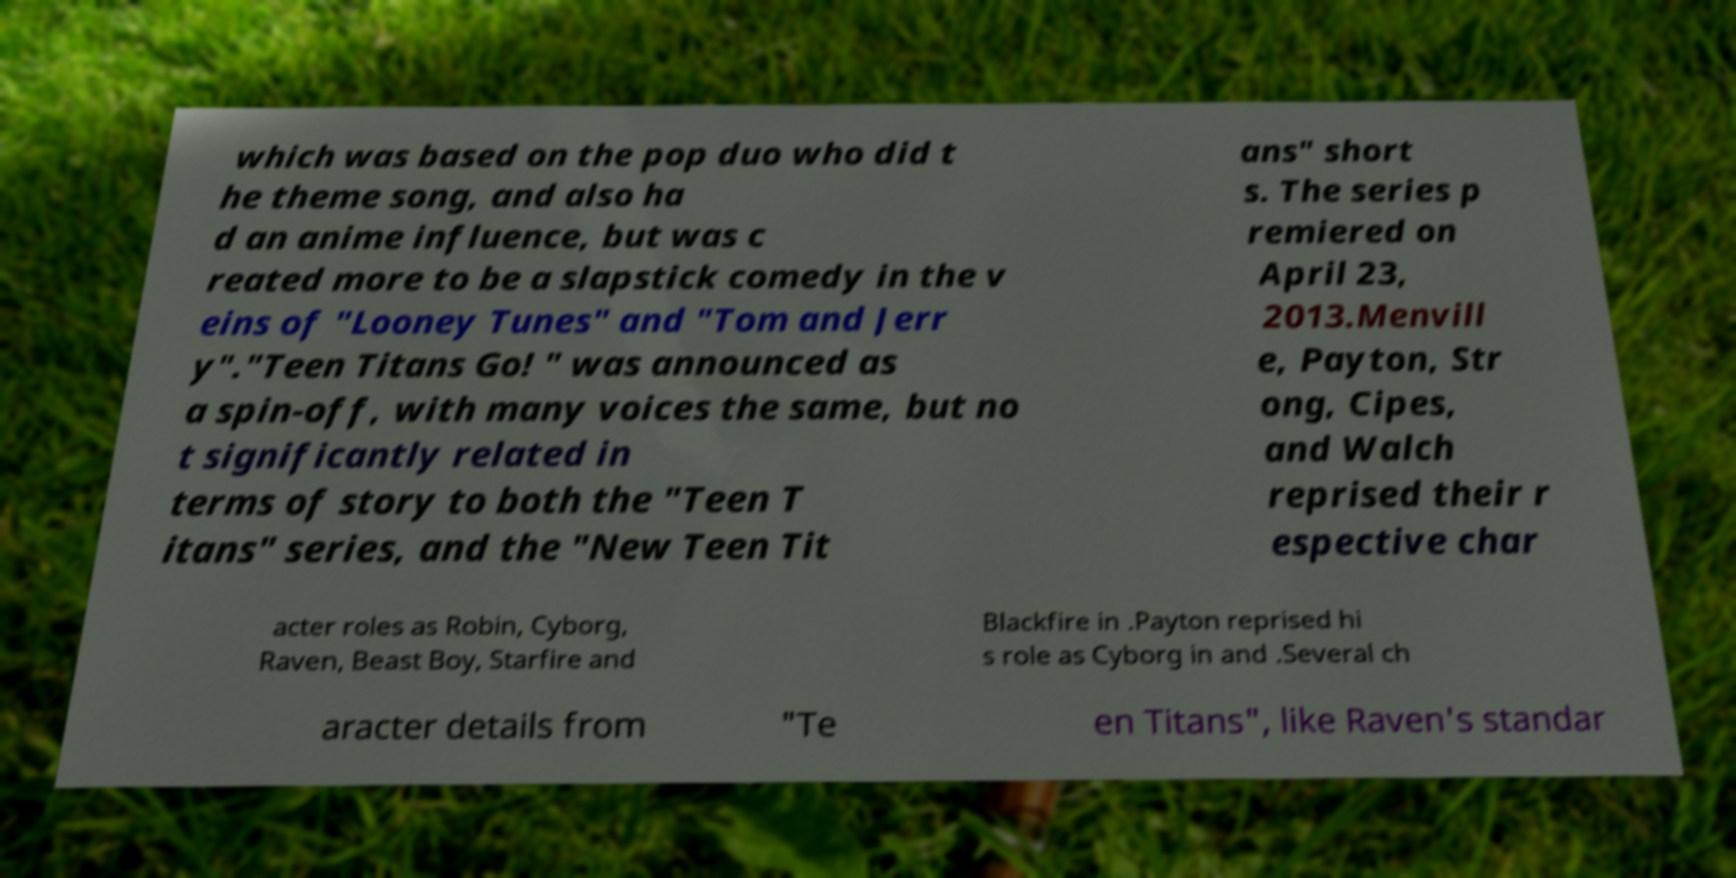Please identify and transcribe the text found in this image. which was based on the pop duo who did t he theme song, and also ha d an anime influence, but was c reated more to be a slapstick comedy in the v eins of "Looney Tunes" and "Tom and Jerr y"."Teen Titans Go! " was announced as a spin-off, with many voices the same, but no t significantly related in terms of story to both the "Teen T itans" series, and the "New Teen Tit ans" short s. The series p remiered on April 23, 2013.Menvill e, Payton, Str ong, Cipes, and Walch reprised their r espective char acter roles as Robin, Cyborg, Raven, Beast Boy, Starfire and Blackfire in .Payton reprised hi s role as Cyborg in and .Several ch aracter details from "Te en Titans", like Raven's standar 